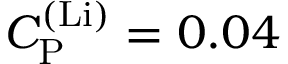Convert formula to latex. <formula><loc_0><loc_0><loc_500><loc_500>C _ { P } ^ { ( L i ) } = 0 . 0 4</formula> 